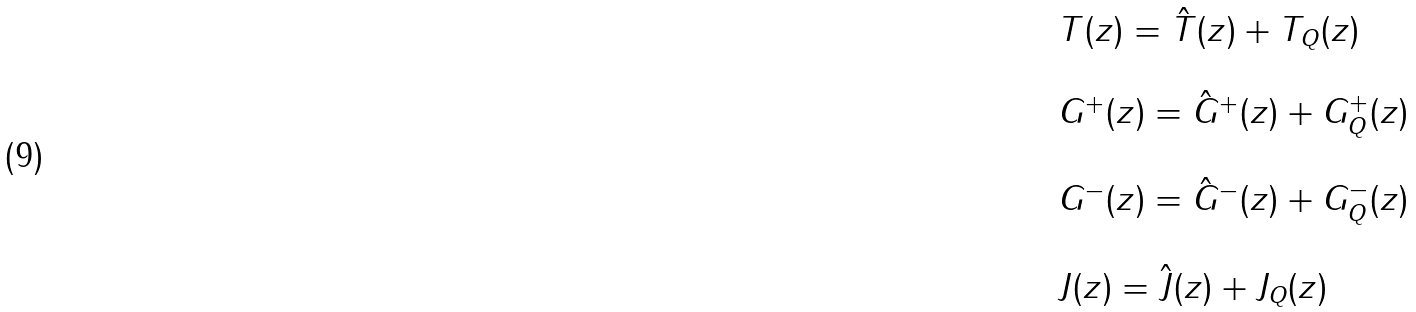<formula> <loc_0><loc_0><loc_500><loc_500>\begin{array} { l } T ( z ) = \hat { T } ( z ) + T _ { Q } ( z ) \\ \ \\ G ^ { + } ( z ) = \hat { G } ^ { + } ( z ) + G ^ { + } _ { Q } ( z ) \\ \ \\ G ^ { - } ( z ) = \hat { G } ^ { - } ( z ) + G ^ { - } _ { Q } ( z ) \\ \ \\ J ( z ) = \hat { J } ( z ) + J _ { Q } ( z ) \end{array}</formula> 